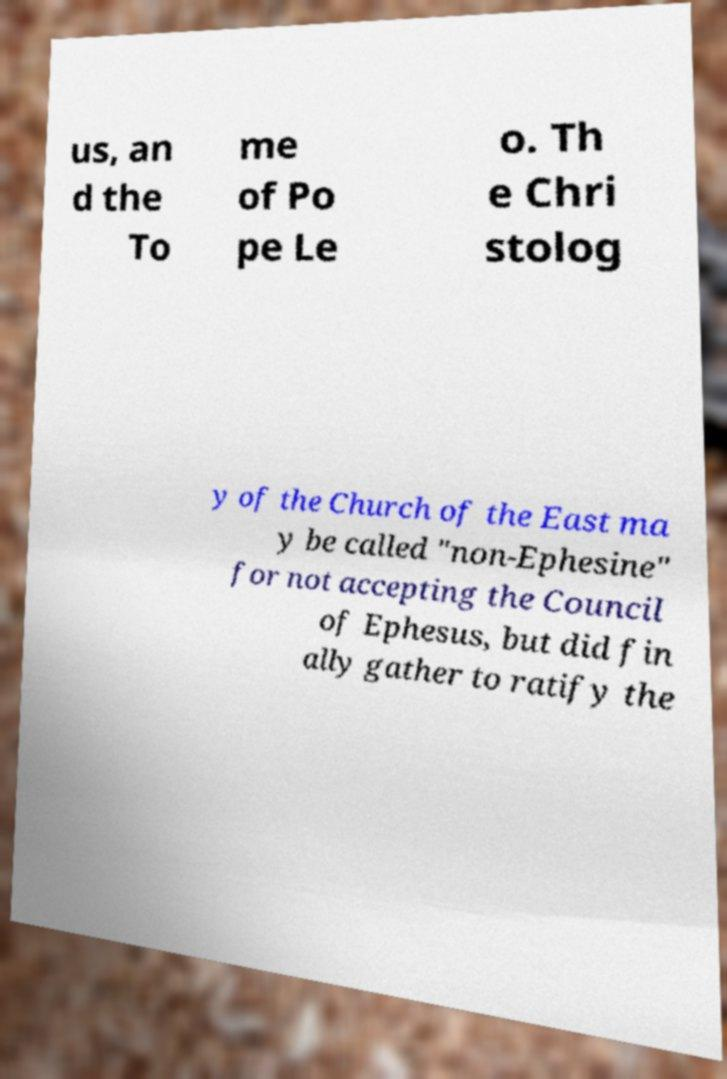There's text embedded in this image that I need extracted. Can you transcribe it verbatim? us, an d the To me of Po pe Le o. Th e Chri stolog y of the Church of the East ma y be called "non-Ephesine" for not accepting the Council of Ephesus, but did fin ally gather to ratify the 